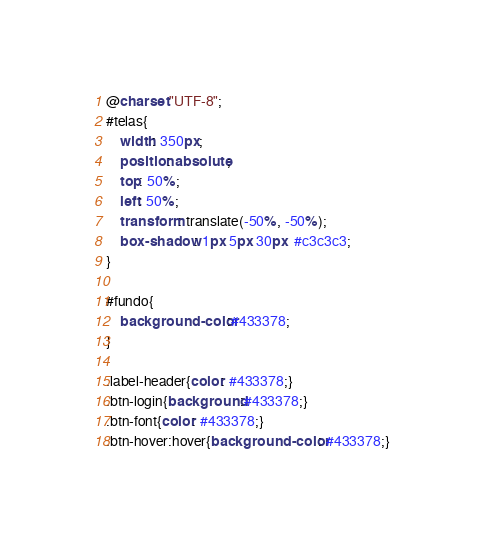<code> <loc_0><loc_0><loc_500><loc_500><_CSS_>@charset "UTF-8";
#telas{
	width: 350px;
	position: absolute;
	top: 50%;
	left: 50%;
	transform: translate(-50%, -50%);
	box-shadow: 1px 5px 30px  #c3c3c3;
}

#fundo{
	background-color:#433378;
}

.label-header{color: #433378;}
.btn-login{background:#433378;}
.btn-font{color: #433378;}
.btn-hover:hover{background-color: #433378;}
</code> 